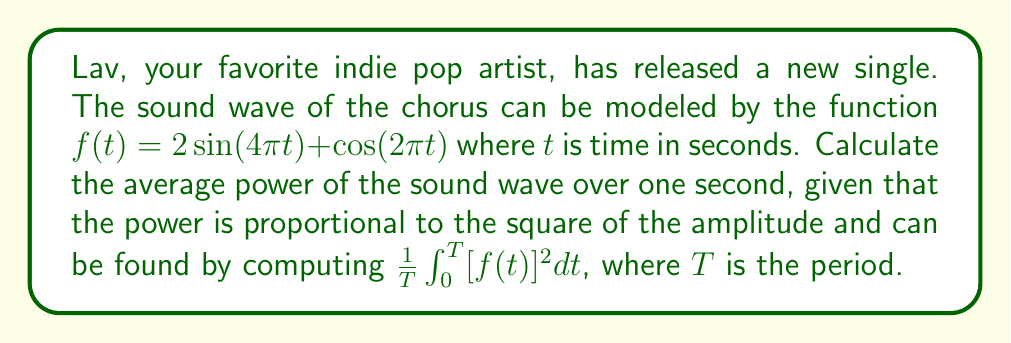Can you answer this question? To solve this problem, we'll follow these steps:

1) First, we need to find the period $T$. The period of $\sin(4\pi t)$ is $\frac{1}{2}$ and the period of $\cos(2\pi t)$ is $1$. The least common multiple of these is $1$, so $T = 1$.

2) We need to compute $\int_0^1 [f(t)]^2 dt$. Let's expand $[f(t)]^2$:

   $[f(t)]^2 = (2\sin(4\pi t) + \cos(2\pi t))^2$
   $= 4\sin^2(4\pi t) + 4\sin(4\pi t)\cos(2\pi t) + \cos^2(2\pi t)$

3) Now we integrate each term:

   $\int_0^1 4\sin^2(4\pi t) dt = 2 - \frac{\sin(8\pi t)}{2\pi}|_0^1 = 2$

   $\int_0^1 4\sin(4\pi t)\cos(2\pi t) dt = \frac{2\sin(6\pi t)}{3\pi} - \frac{2\sin(2\pi t)}{\pi}|_0^1 = 0$

   $\int_0^1 \cos^2(2\pi t) dt = \frac{1}{2} + \frac{\sin(4\pi t)}{4\pi}|_0^1 = \frac{1}{2}$

4) Sum these results:

   $\int_0^1 [f(t)]^2 dt = 2 + 0 + \frac{1}{2} = \frac{5}{2}$

5) Finally, we compute the average power:

   $\frac{1}{T}\int_0^T [f(t)]^2 dt = \frac{1}{1} \cdot \frac{5}{2} = \frac{5}{2}$
Answer: $\frac{5}{2}$ 